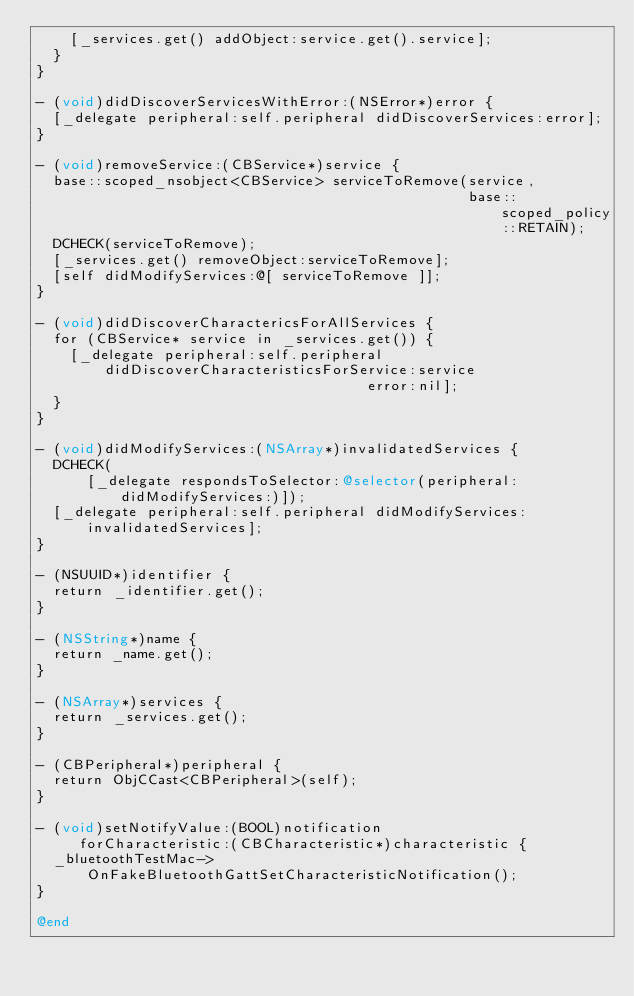<code> <loc_0><loc_0><loc_500><loc_500><_ObjectiveC_>    [_services.get() addObject:service.get().service];
  }
}

- (void)didDiscoverServicesWithError:(NSError*)error {
  [_delegate peripheral:self.peripheral didDiscoverServices:error];
}

- (void)removeService:(CBService*)service {
  base::scoped_nsobject<CBService> serviceToRemove(service,
                                                   base::scoped_policy::RETAIN);
  DCHECK(serviceToRemove);
  [_services.get() removeObject:serviceToRemove];
  [self didModifyServices:@[ serviceToRemove ]];
}

- (void)didDiscoverCharactericsForAllServices {
  for (CBService* service in _services.get()) {
    [_delegate peripheral:self.peripheral
        didDiscoverCharacteristicsForService:service
                                       error:nil];
  }
}

- (void)didModifyServices:(NSArray*)invalidatedServices {
  DCHECK(
      [_delegate respondsToSelector:@selector(peripheral:didModifyServices:)]);
  [_delegate peripheral:self.peripheral didModifyServices:invalidatedServices];
}

- (NSUUID*)identifier {
  return _identifier.get();
}

- (NSString*)name {
  return _name.get();
}

- (NSArray*)services {
  return _services.get();
}

- (CBPeripheral*)peripheral {
  return ObjCCast<CBPeripheral>(self);
}

- (void)setNotifyValue:(BOOL)notification
     forCharacteristic:(CBCharacteristic*)characteristic {
  _bluetoothTestMac->OnFakeBluetoothGattSetCharacteristicNotification();
}

@end
</code> 